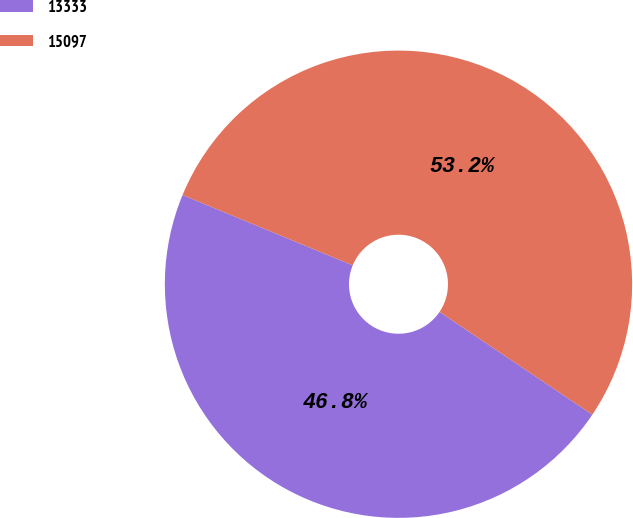Convert chart. <chart><loc_0><loc_0><loc_500><loc_500><pie_chart><fcel>13333<fcel>15097<nl><fcel>46.81%<fcel>53.19%<nl></chart> 